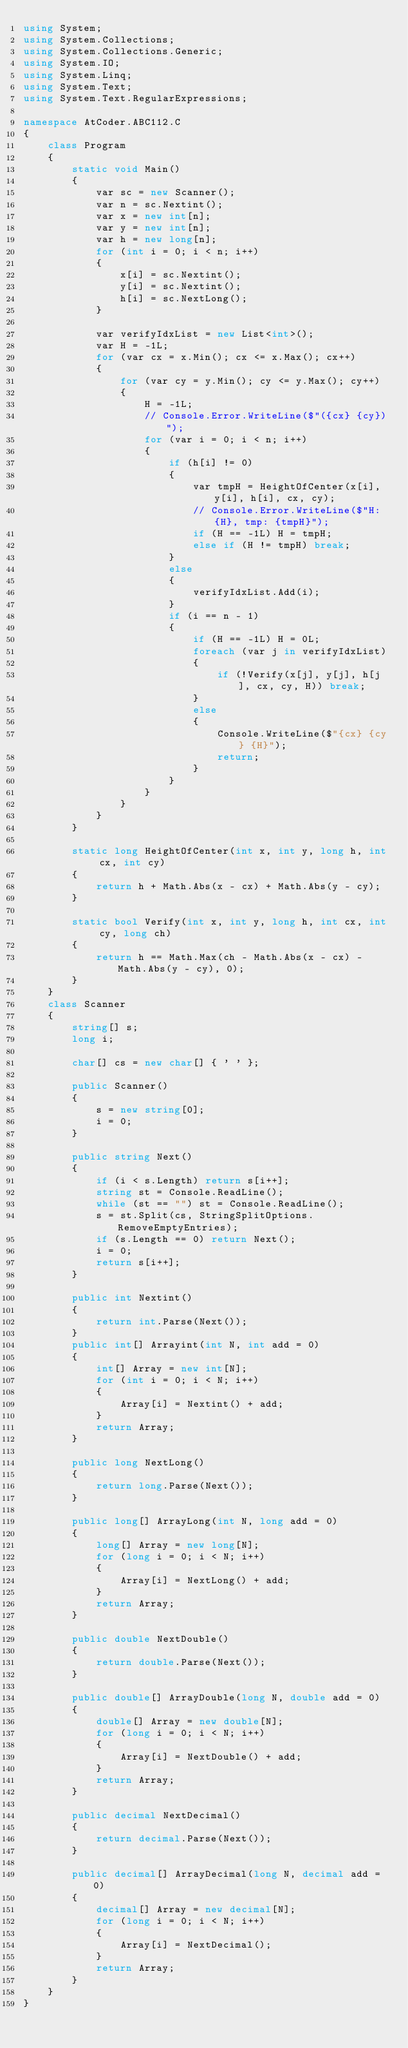<code> <loc_0><loc_0><loc_500><loc_500><_C#_>using System;
using System.Collections;
using System.Collections.Generic;
using System.IO;
using System.Linq;
using System.Text;
using System.Text.RegularExpressions;

namespace AtCoder.ABC112.C
{
    class Program
    {
        static void Main()
        {
            var sc = new Scanner();
            var n = sc.Nextint();
            var x = new int[n];
            var y = new int[n];
            var h = new long[n];
            for (int i = 0; i < n; i++)
            {
                x[i] = sc.Nextint();
                y[i] = sc.Nextint();
                h[i] = sc.NextLong();
            }

            var verifyIdxList = new List<int>();
            var H = -1L;
            for (var cx = x.Min(); cx <= x.Max(); cx++)
            {
                for (var cy = y.Min(); cy <= y.Max(); cy++)
                {
                    H = -1L;
                    // Console.Error.WriteLine($"({cx} {cy})");
                    for (var i = 0; i < n; i++)
                    {
                        if (h[i] != 0)
                        {
                            var tmpH = HeightOfCenter(x[i], y[i], h[i], cx, cy);
                            // Console.Error.WriteLine($"H: {H}, tmp: {tmpH}");
                            if (H == -1L) H = tmpH;
                            else if (H != tmpH) break;
                        }
                        else
                        {
                            verifyIdxList.Add(i);
                        }
                        if (i == n - 1)
                        {
                            if (H == -1L) H = 0L;
                            foreach (var j in verifyIdxList)
                            {
                                if (!Verify(x[j], y[j], h[j], cx, cy, H)) break;
                            }
                            else
                            {
                                Console.WriteLine($"{cx} {cy} {H}");
                                return;
                            }
                        }
                    }
                }
            }
        }

        static long HeightOfCenter(int x, int y, long h, int cx, int cy)
        {
            return h + Math.Abs(x - cx) + Math.Abs(y - cy);
        }

        static bool Verify(int x, int y, long h, int cx, int cy, long ch)
        {
            return h == Math.Max(ch - Math.Abs(x - cx) - Math.Abs(y - cy), 0);
        }
    }
    class Scanner
    {
        string[] s;
        long i;

        char[] cs = new char[] { ' ' };

        public Scanner()
        {
            s = new string[0];
            i = 0;
        }

        public string Next()
        {
            if (i < s.Length) return s[i++];
            string st = Console.ReadLine();
            while (st == "") st = Console.ReadLine();
            s = st.Split(cs, StringSplitOptions.RemoveEmptyEntries);
            if (s.Length == 0) return Next();
            i = 0;
            return s[i++];
        }

        public int Nextint()
        {
            return int.Parse(Next());
        }
        public int[] Arrayint(int N, int add = 0)
        {
            int[] Array = new int[N];
            for (int i = 0; i < N; i++)
            {
                Array[i] = Nextint() + add;
            }
            return Array;
        }

        public long NextLong()
        {
            return long.Parse(Next());
        }

        public long[] ArrayLong(int N, long add = 0)
        {
            long[] Array = new long[N];
            for (long i = 0; i < N; i++)
            {
                Array[i] = NextLong() + add;
            }
            return Array;
        }

        public double NextDouble()
        {
            return double.Parse(Next());
        }

        public double[] ArrayDouble(long N, double add = 0)
        {
            double[] Array = new double[N];
            for (long i = 0; i < N; i++)
            {
                Array[i] = NextDouble() + add;
            }
            return Array;
        }

        public decimal NextDecimal()
        {
            return decimal.Parse(Next());
        }

        public decimal[] ArrayDecimal(long N, decimal add = 0)
        {
            decimal[] Array = new decimal[N];
            for (long i = 0; i < N; i++)
            {
                Array[i] = NextDecimal();
            }
            return Array;
        }
    }
}
</code> 